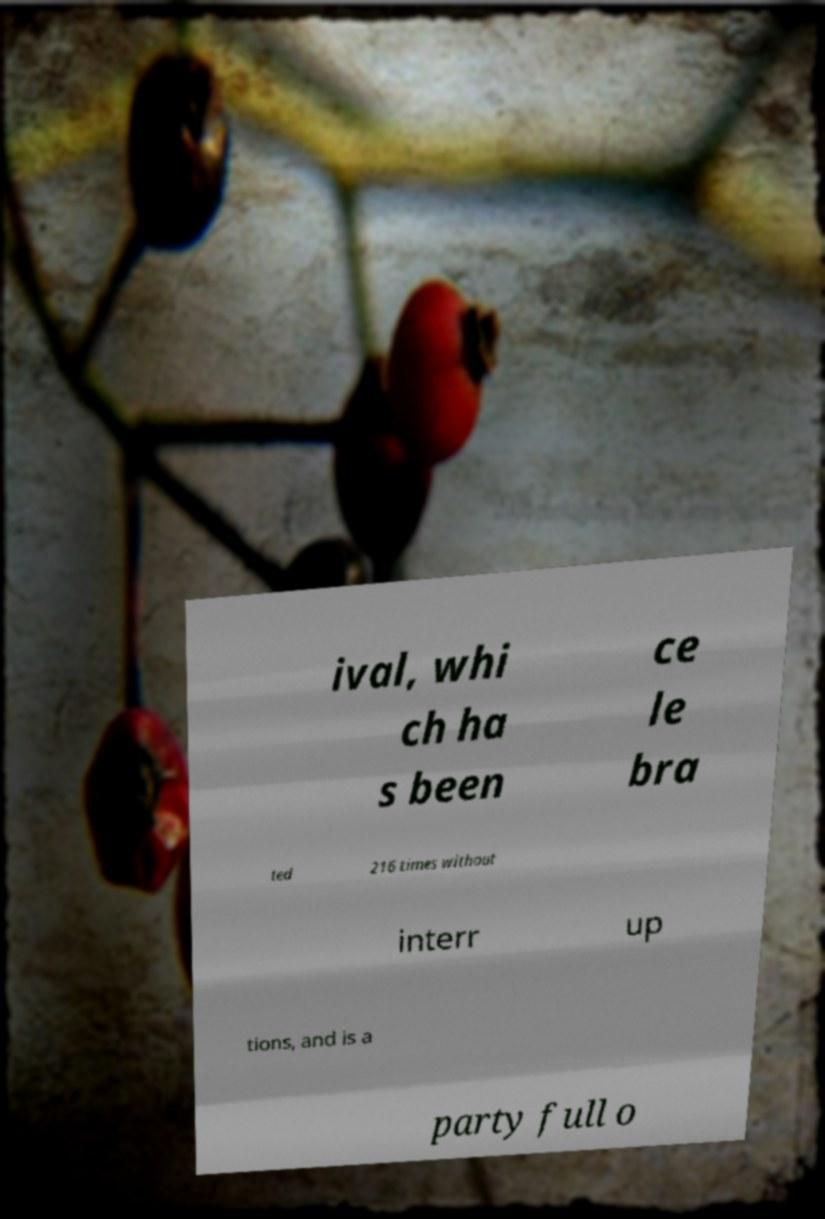I need the written content from this picture converted into text. Can you do that? ival, whi ch ha s been ce le bra ted 216 times without interr up tions, and is a party full o 